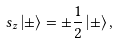Convert formula to latex. <formula><loc_0><loc_0><loc_500><loc_500>s _ { z } \left | \pm \right \rangle = \pm \frac { 1 } { 2 } \left | \pm \right \rangle ,</formula> 